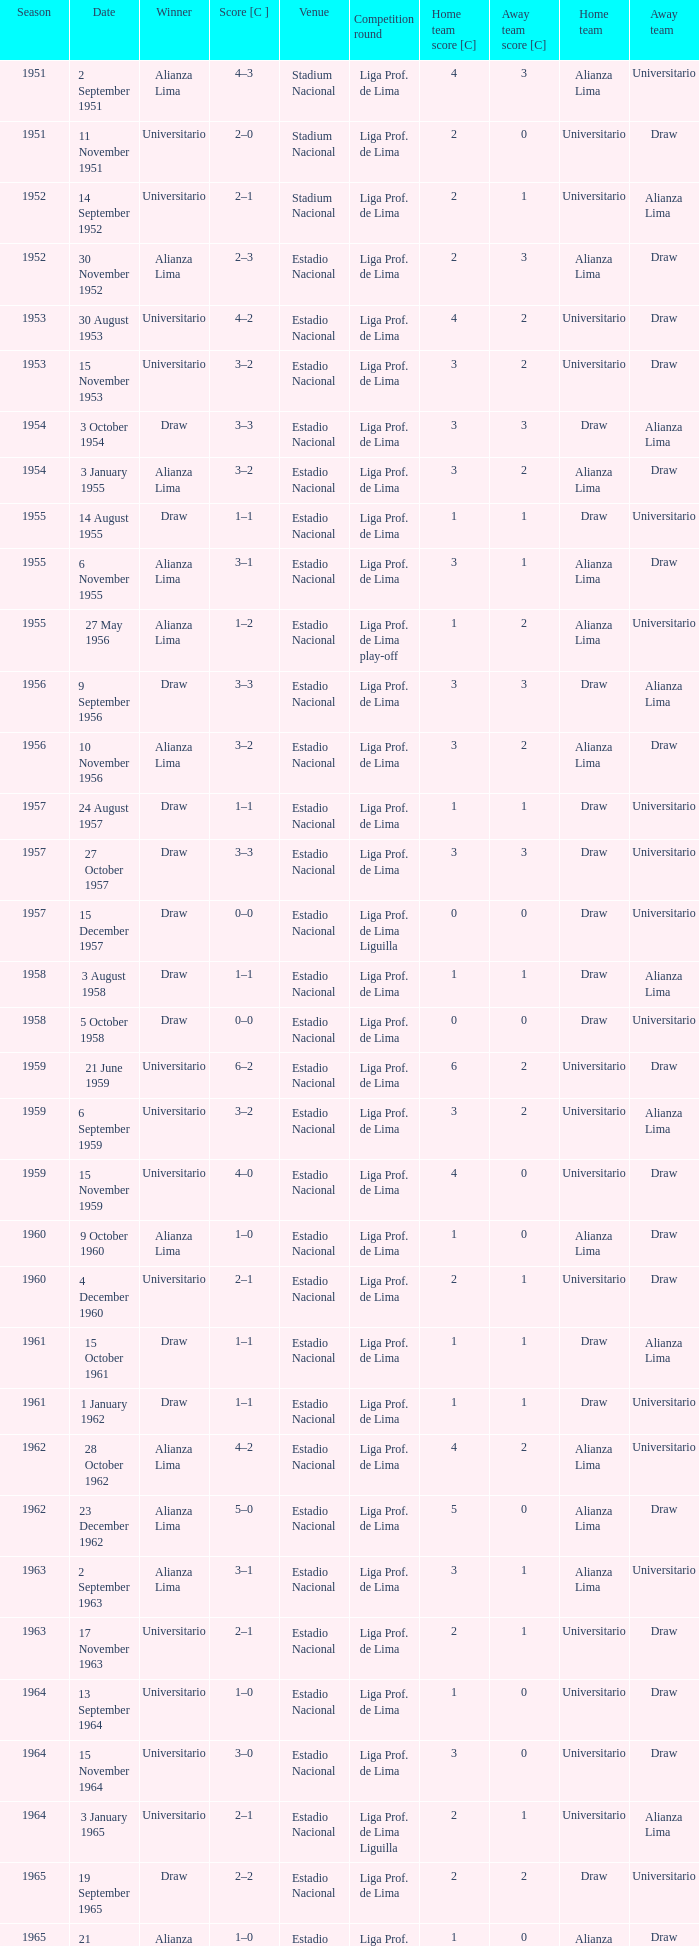What place held an affair on 17 november 1963? Estadio Nacional. 